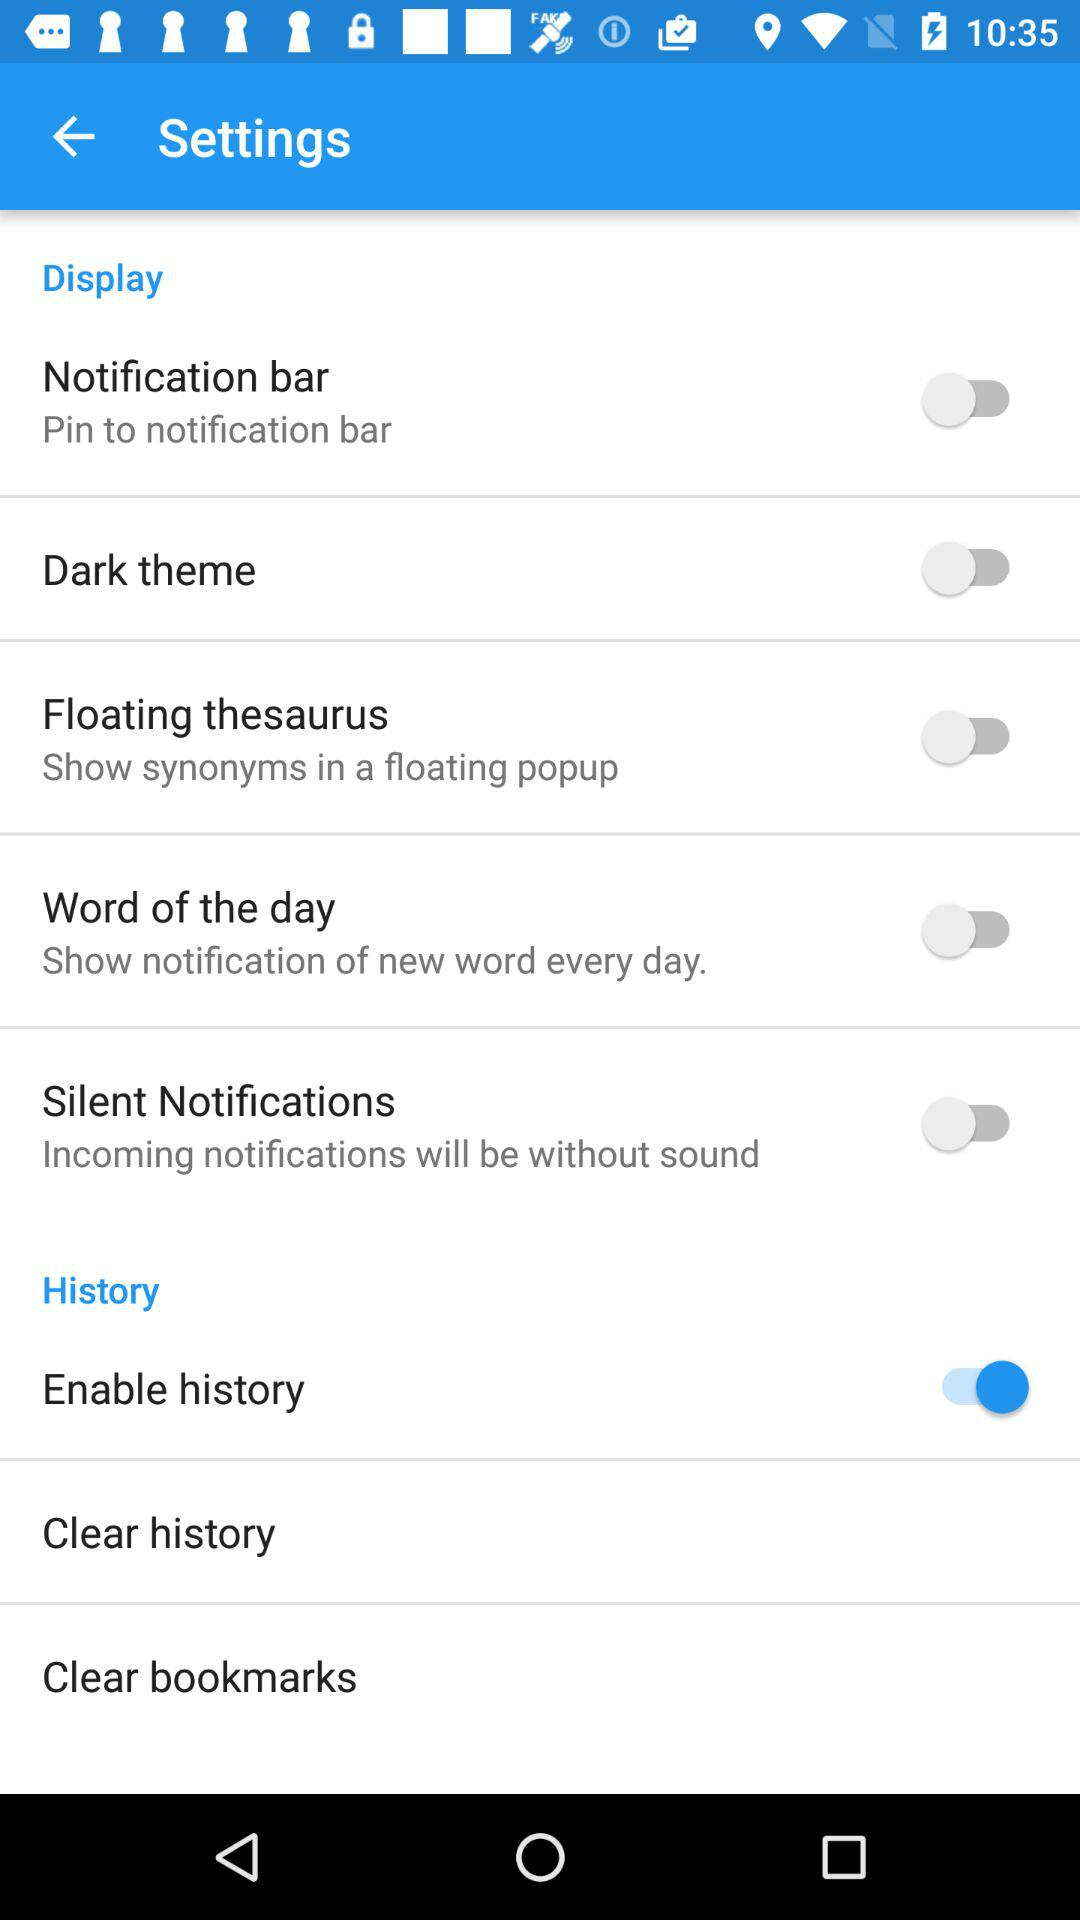How many items are in the 'History' section?
Answer the question using a single word or phrase. 3 